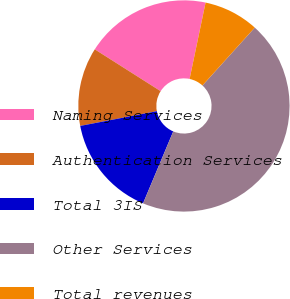<chart> <loc_0><loc_0><loc_500><loc_500><pie_chart><fcel>Naming Services<fcel>Authentication Services<fcel>Total 3IS<fcel>Other Services<fcel>Total revenues<nl><fcel>19.28%<fcel>12.03%<fcel>15.65%<fcel>44.63%<fcel>8.41%<nl></chart> 